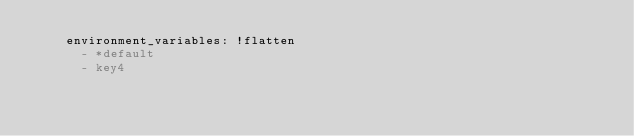Convert code to text. <code><loc_0><loc_0><loc_500><loc_500><_YAML_>    environment_variables: !flatten
      - *default
      - key4</code> 